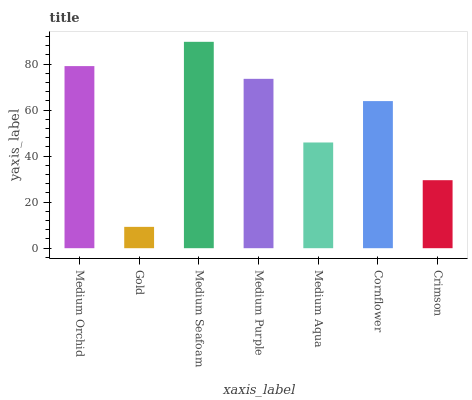Is Gold the minimum?
Answer yes or no. Yes. Is Medium Seafoam the maximum?
Answer yes or no. Yes. Is Medium Seafoam the minimum?
Answer yes or no. No. Is Gold the maximum?
Answer yes or no. No. Is Medium Seafoam greater than Gold?
Answer yes or no. Yes. Is Gold less than Medium Seafoam?
Answer yes or no. Yes. Is Gold greater than Medium Seafoam?
Answer yes or no. No. Is Medium Seafoam less than Gold?
Answer yes or no. No. Is Cornflower the high median?
Answer yes or no. Yes. Is Cornflower the low median?
Answer yes or no. Yes. Is Medium Seafoam the high median?
Answer yes or no. No. Is Gold the low median?
Answer yes or no. No. 